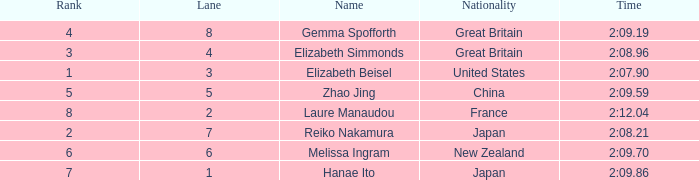What is Elizabeth Simmonds' average lane number? 4.0. 